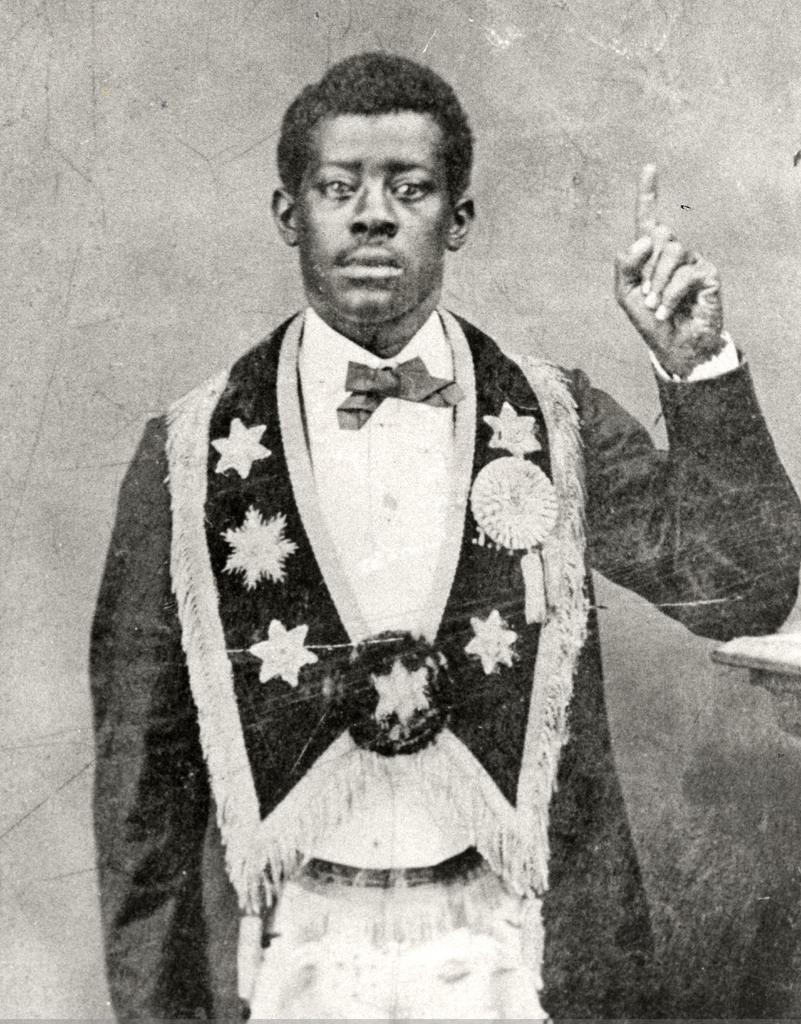What is the color scheme of the image? The image is black and white. Can you describe the main subject in the image? There is a person in the image. What can be seen in the background of the image? There is a wall in the background of the image. What type of bubble can be seen in the image? There is no bubble present in the image. Can you describe the level of detail in the person's clothing in the image? The image is black and white, so it is difficult to discern the level of detail in the person's clothing. 